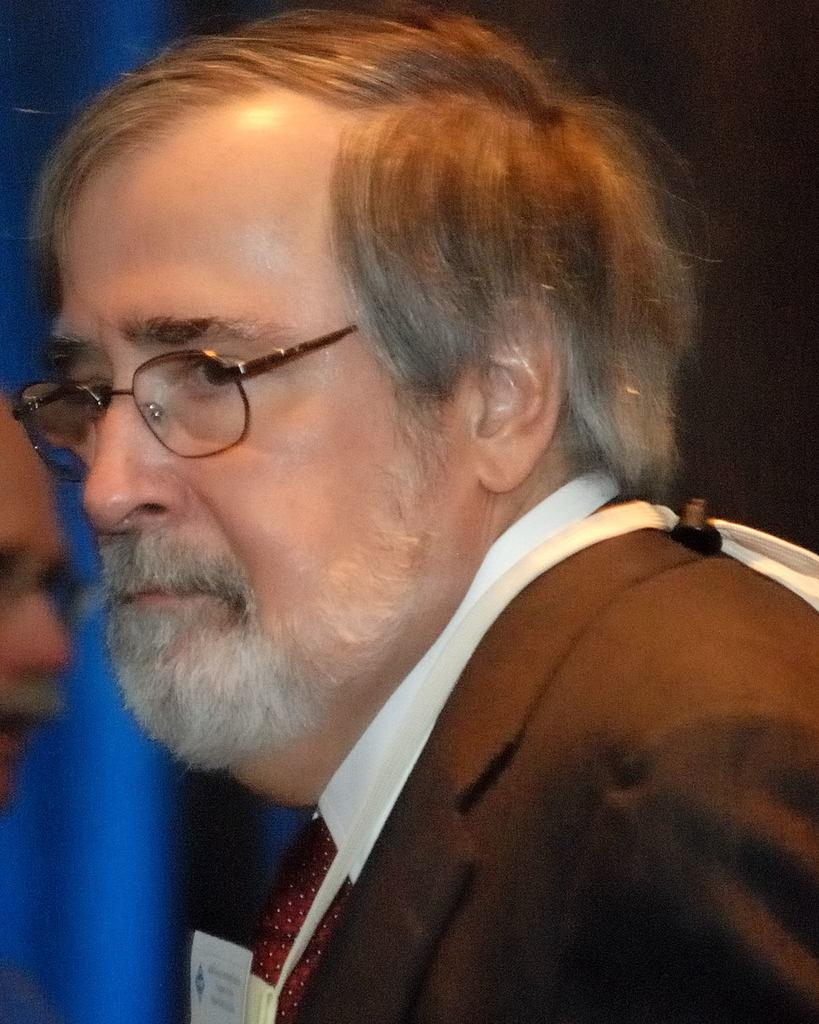Who is the main subject in the center of the image? There is a man in the center of the image. What is the man wearing in the image? The man is wearing a suit, a tie, and spectacles. Who else is present in the image? There is a person on the left side of the image. What can be seen on the left side of the image? There is a blue light on the left side of the image. How would you describe the overall setting of the image? The background of the image is dark. What is the rate of the man's heartbeat in the image? There is no information about the man's heartbeat in the image, so it cannot be determined. What is the chance of the person on the left side of the image winning a lottery? There is no information about a lottery or any related events in the image, so it cannot be determined. 